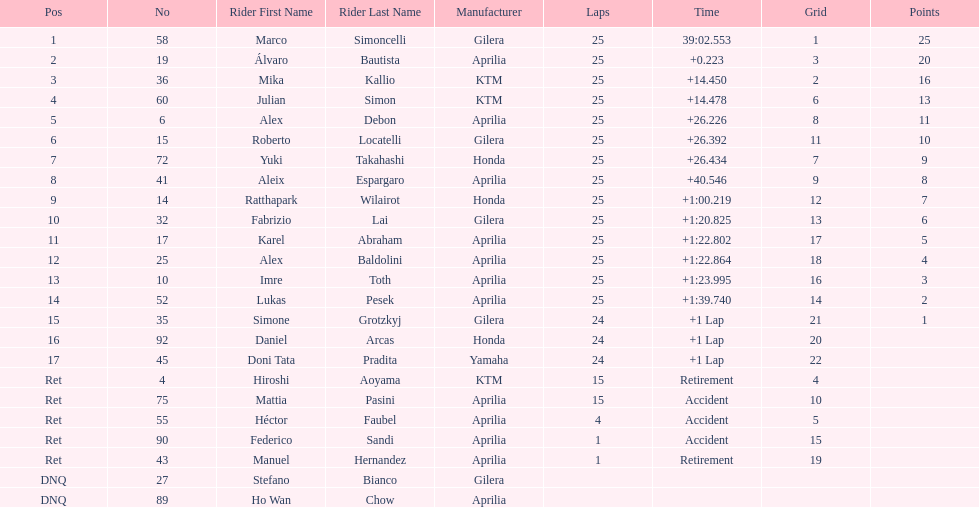Who is marco simoncelli's manufacturer Gilera. 